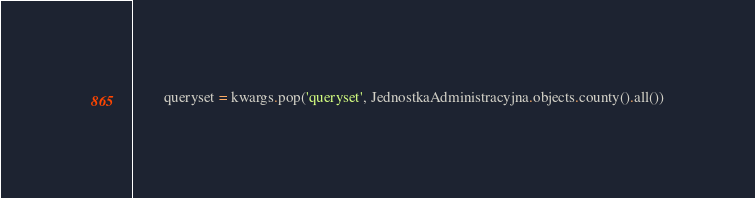Convert code to text. <code><loc_0><loc_0><loc_500><loc_500><_Python_>        queryset = kwargs.pop('queryset', JednostkaAdministracyjna.objects.county().all())</code> 